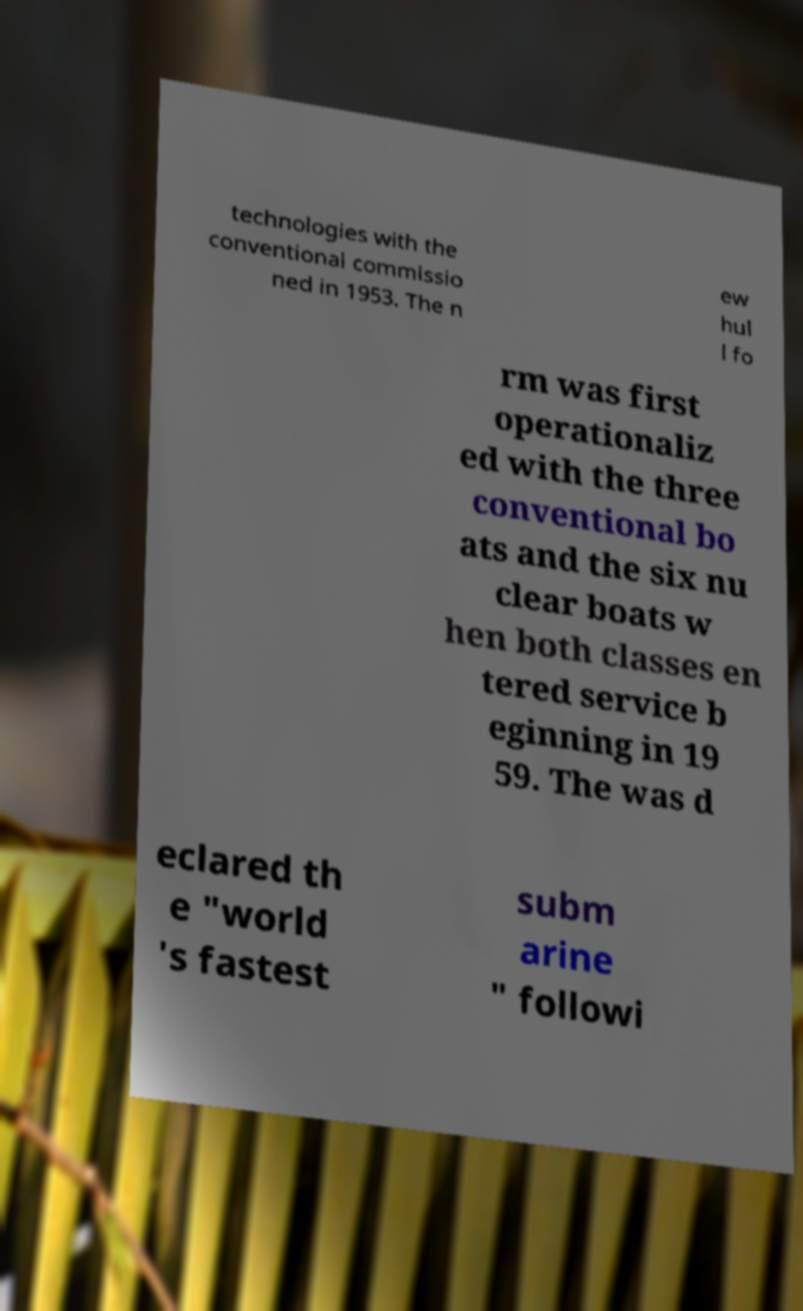I need the written content from this picture converted into text. Can you do that? technologies with the conventional commissio ned in 1953. The n ew hul l fo rm was first operationaliz ed with the three conventional bo ats and the six nu clear boats w hen both classes en tered service b eginning in 19 59. The was d eclared th e "world 's fastest subm arine " followi 